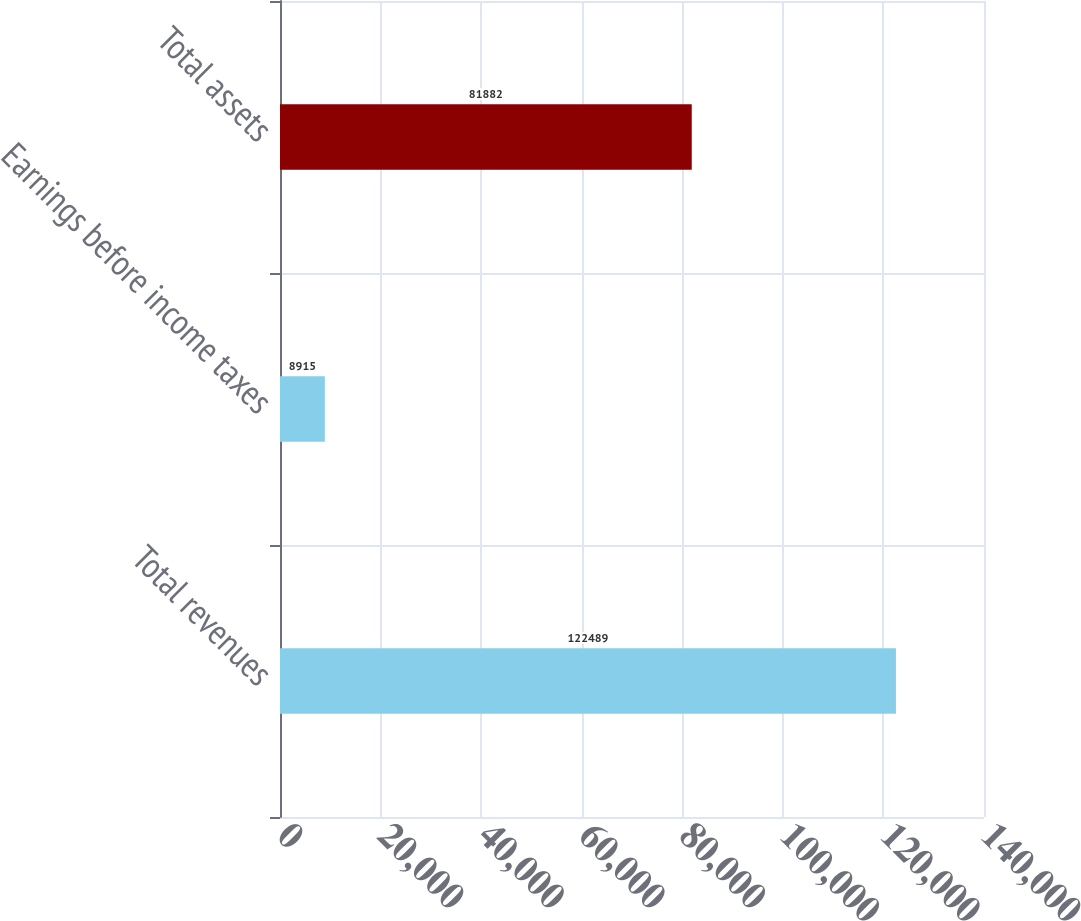<chart> <loc_0><loc_0><loc_500><loc_500><bar_chart><fcel>Total revenues<fcel>Earnings before income taxes<fcel>Total assets<nl><fcel>122489<fcel>8915<fcel>81882<nl></chart> 